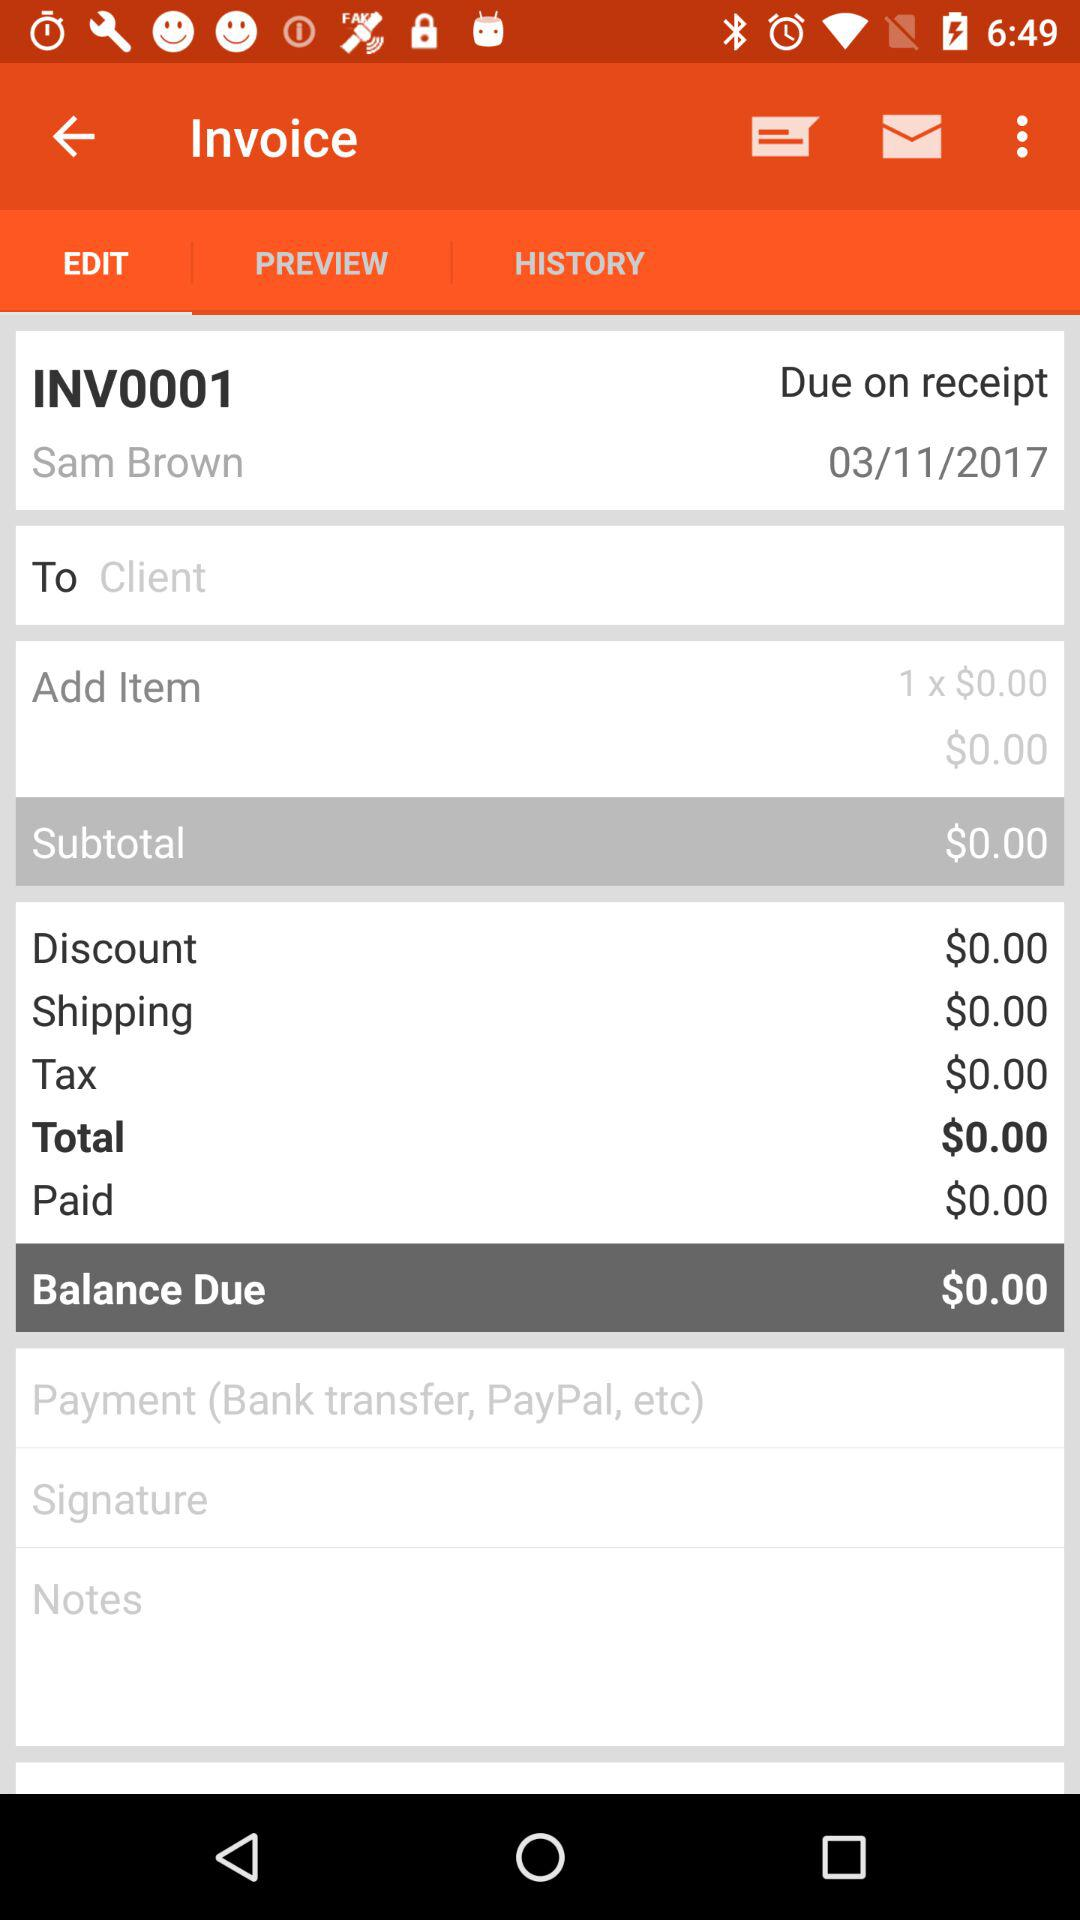What is the name of the user? The name of the user is Sam Brown. 